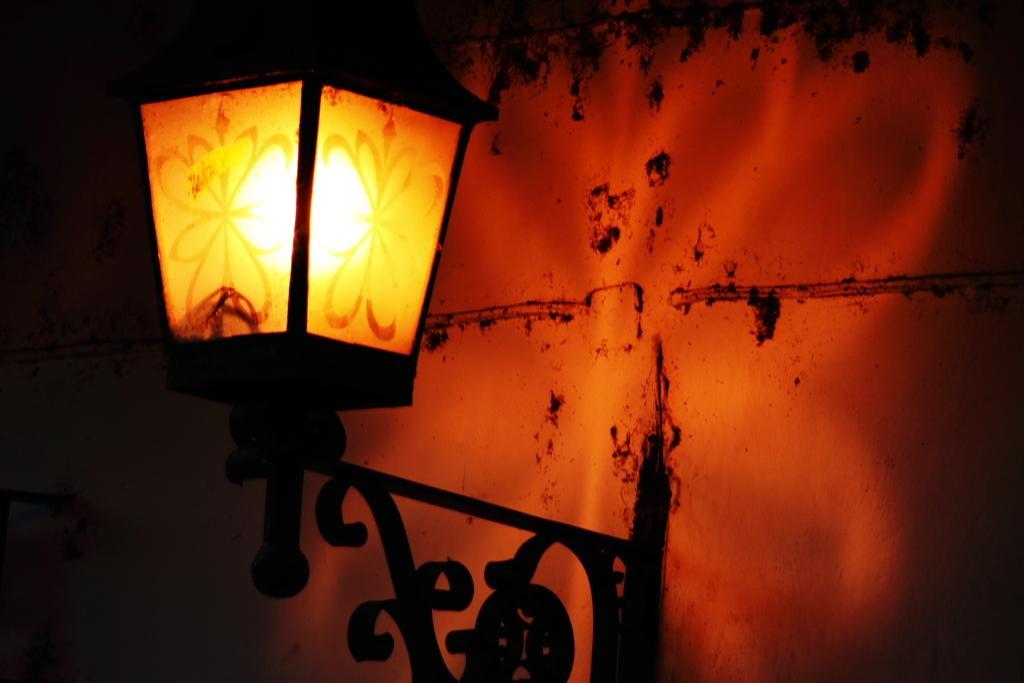How would you summarize this image in a sentence or two? In this image I can see a black color lamp. I can see a wall and yellow,red color light. 